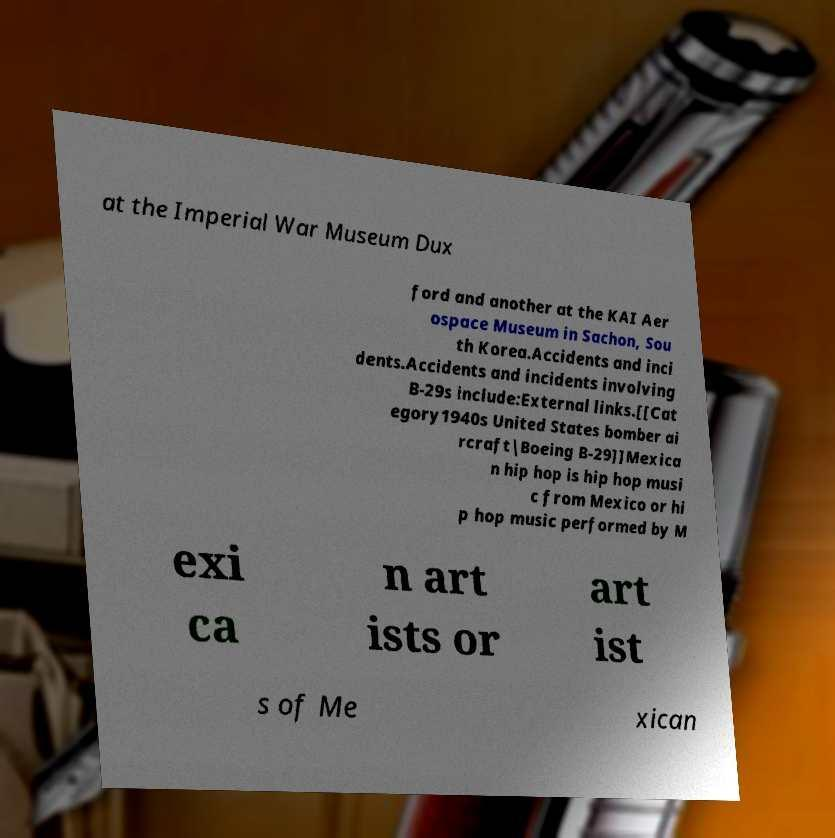Can you read and provide the text displayed in the image?This photo seems to have some interesting text. Can you extract and type it out for me? at the Imperial War Museum Dux ford and another at the KAI Aer ospace Museum in Sachon, Sou th Korea.Accidents and inci dents.Accidents and incidents involving B-29s include:External links.[[Cat egory1940s United States bomber ai rcraft|Boeing B-29]]Mexica n hip hop is hip hop musi c from Mexico or hi p hop music performed by M exi ca n art ists or art ist s of Me xican 